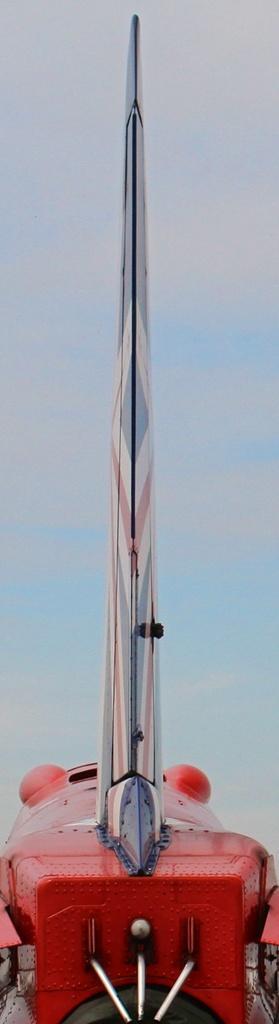Describe this image in one or two sentences. In this image I see a red color thing and it is white and blue in the background and I see the silver color things on this thing. 